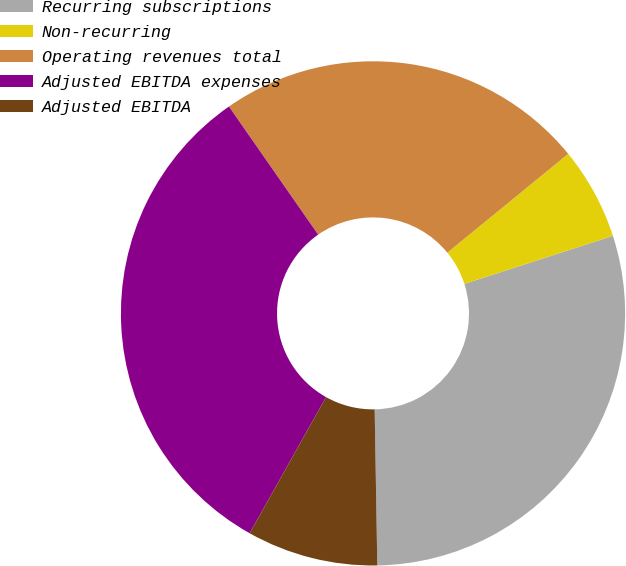<chart> <loc_0><loc_0><loc_500><loc_500><pie_chart><fcel>Recurring subscriptions<fcel>Non-recurring<fcel>Operating revenues total<fcel>Adjusted EBITDA expenses<fcel>Adjusted EBITDA<nl><fcel>29.71%<fcel>5.93%<fcel>23.78%<fcel>32.18%<fcel>8.41%<nl></chart> 